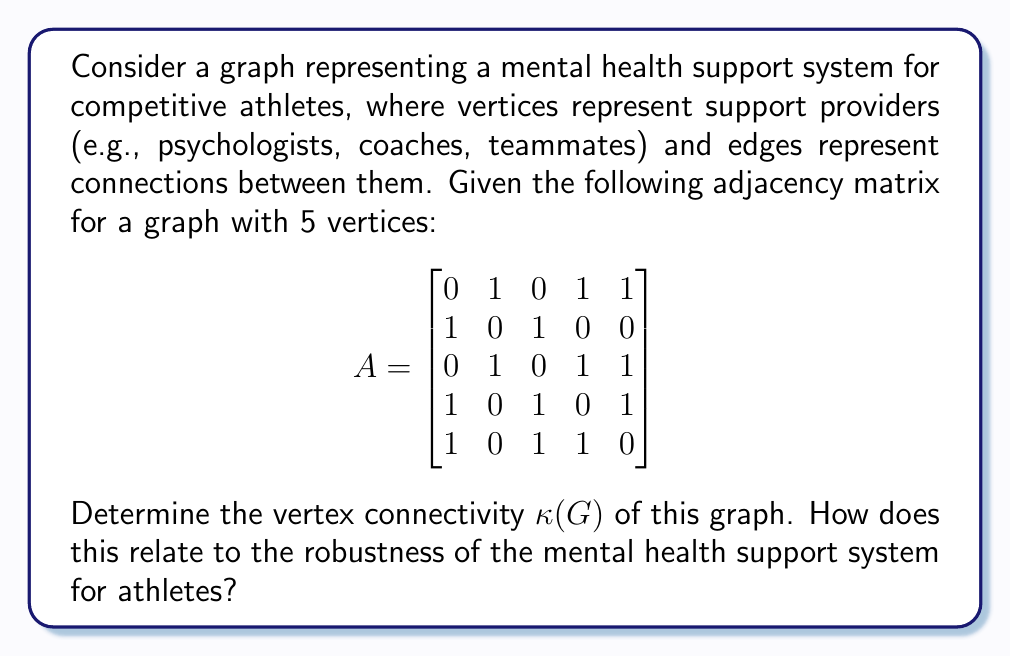Give your solution to this math problem. To determine the vertex connectivity $\kappa(G)$ of the graph, we need to find the minimum number of vertices whose removal would disconnect the graph. Let's approach this step-by-step:

1. First, we need to understand what the adjacency matrix tells us:
   - The graph has 5 vertices (5x5 matrix)
   - An entry of 1 indicates an edge between vertices, 0 indicates no edge

2. Let's visualize the graph:
[asy]
unitsize(1cm);
pair[] v = {(0,0), (2,1), (4,0), (3,-2), (1,-2)};
for(int i = 0; i < 5; ++i) {
  dot(v[i]);
  label("v" + string(i+1), v[i], N);
}
draw(v[0]--v[1]--v[2]--v[3]--v[4]--v[0]);
draw(v[0]--v[3]);
draw(v[2]--v[4]);
[/asy]

3. To find $\kappa(G)$, we need to identify the minimum cut set:
   - Removing v1 doesn't disconnect the graph
   - Removing v2 doesn't disconnect the graph
   - Removing v3 doesn't disconnect the graph
   - Removing v4 doesn't disconnect the graph
   - Removing v5 doesn't disconnect the graph

4. We need to try removing pairs of vertices:
   - Removing v1 and v3 disconnects the graph
   - This is the minimum number of vertices needed to disconnect the graph

5. Therefore, the vertex connectivity $\kappa(G) = 2$

Relating this to the mental health support system for athletes:
- The vertex connectivity represents the minimum number of support providers that, if removed, would break down the entire support system.
- A higher vertex connectivity indicates a more robust support system.
- In this case, $\kappa(G) = 2$ suggests that the system is somewhat vulnerable, as removing just two key providers could potentially disrupt the entire support network.
- This highlights the importance of having multiple, well-connected support providers to ensure the mental health needs of competitive athletes are met, even if some providers become unavailable.
Answer: The vertex connectivity of the graph is $\kappa(G) = 2$. This indicates that the mental health support system for athletes represented by this graph is moderately vulnerable, as the removal of two key support providers could potentially disconnect the entire support network. 